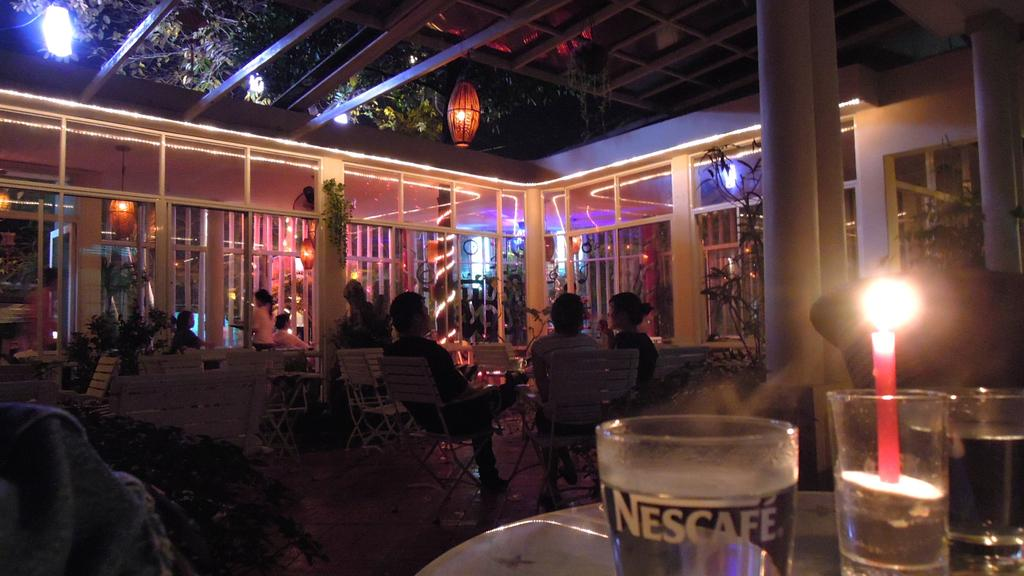<image>
Relay a brief, clear account of the picture shown. Outside backyard dinner with a group of people and a cup saying Nescafe. 